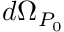Convert formula to latex. <formula><loc_0><loc_0><loc_500><loc_500>d \Omega _ { P _ { 0 } }</formula> 